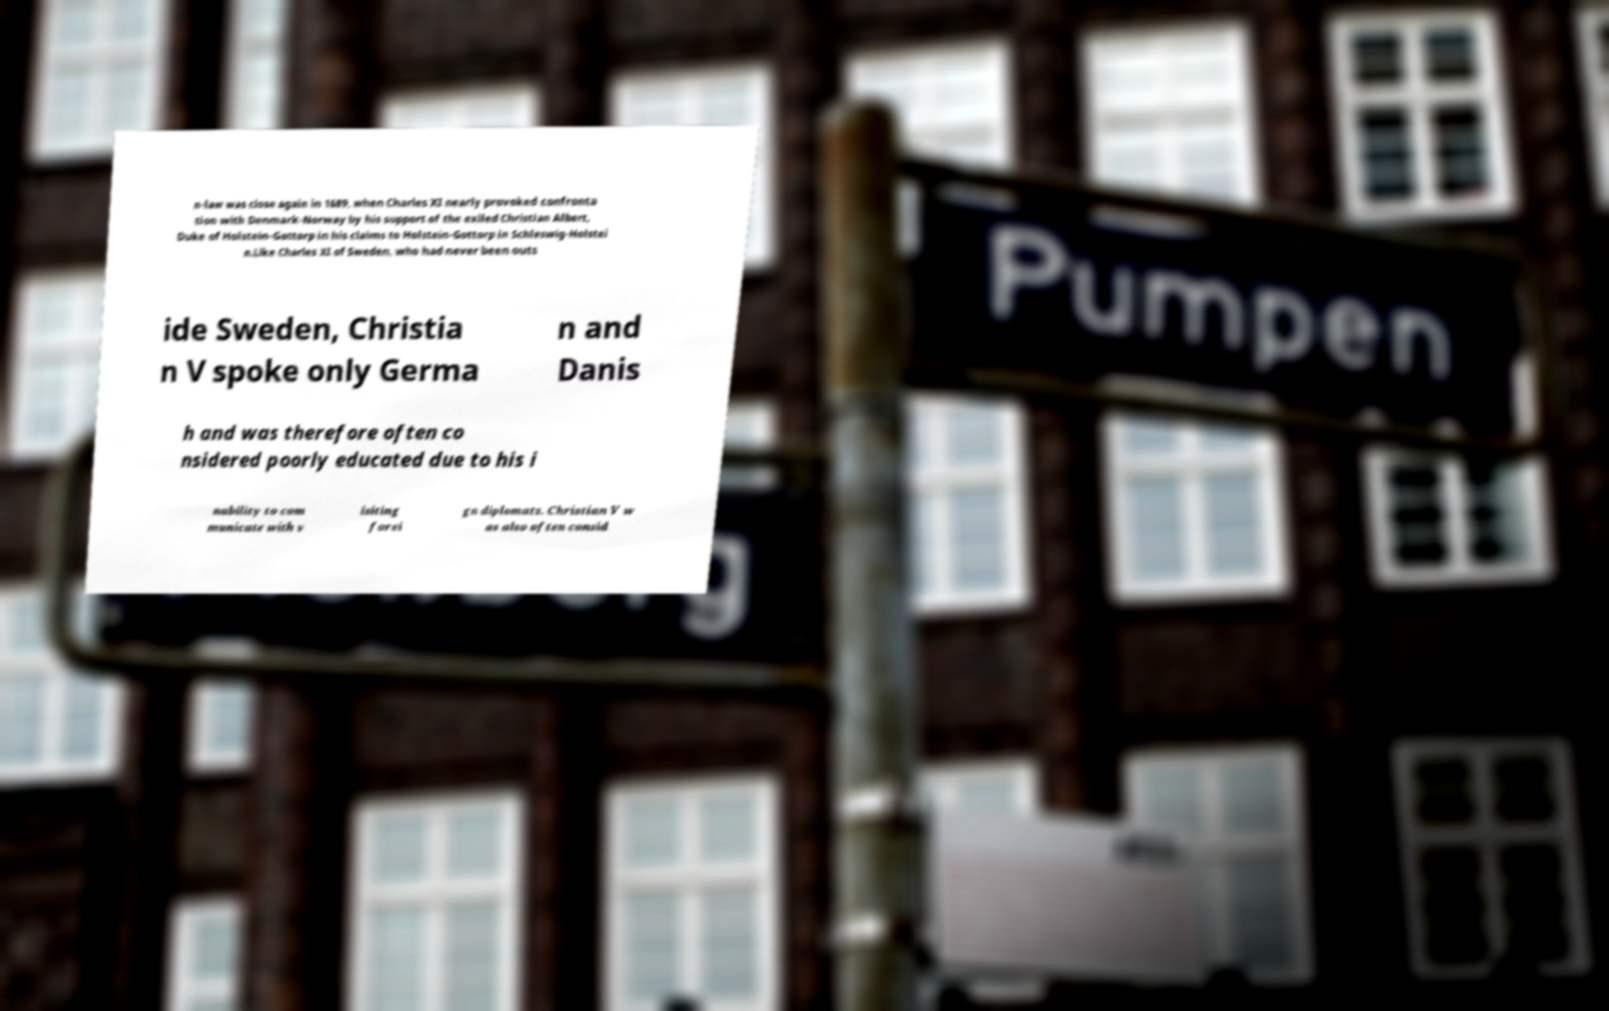For documentation purposes, I need the text within this image transcribed. Could you provide that? n-law was close again in 1689, when Charles XI nearly provoked confronta tion with Denmark-Norway by his support of the exiled Christian Albert, Duke of Holstein-Gottorp in his claims to Holstein-Gottorp in Schleswig-Holstei n.Like Charles XI of Sweden, who had never been outs ide Sweden, Christia n V spoke only Germa n and Danis h and was therefore often co nsidered poorly educated due to his i nability to com municate with v isiting forei gn diplomats. Christian V w as also often consid 